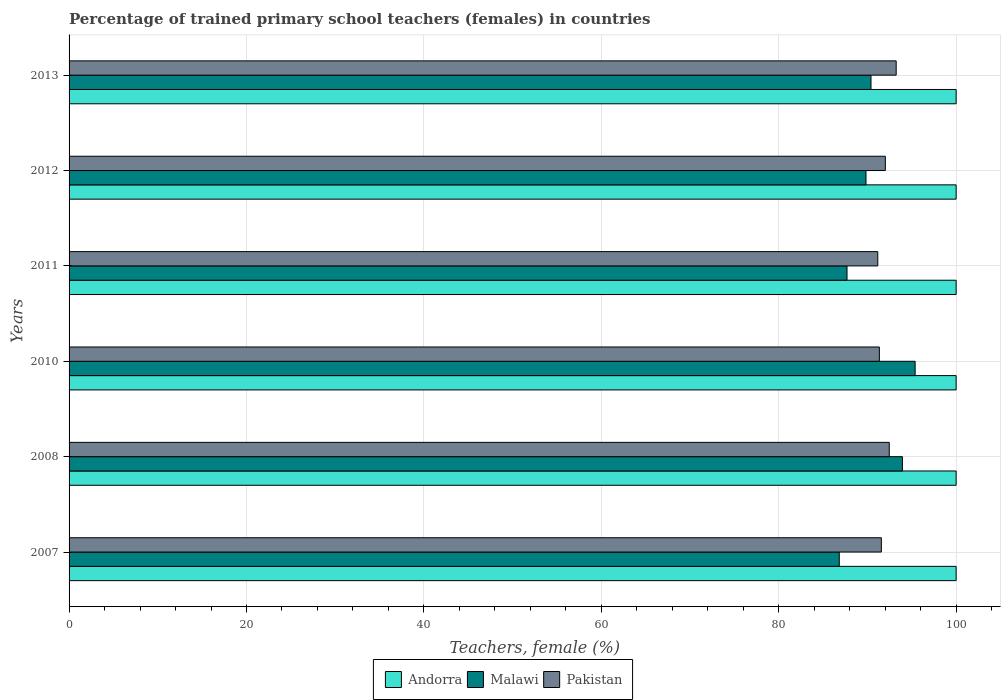How many different coloured bars are there?
Provide a succinct answer. 3. How many bars are there on the 3rd tick from the bottom?
Ensure brevity in your answer.  3. In how many cases, is the number of bars for a given year not equal to the number of legend labels?
Your response must be concise. 0. What is the percentage of trained primary school teachers (females) in Pakistan in 2013?
Ensure brevity in your answer.  93.24. Across all years, what is the maximum percentage of trained primary school teachers (females) in Malawi?
Make the answer very short. 95.38. Across all years, what is the minimum percentage of trained primary school teachers (females) in Pakistan?
Your response must be concise. 91.17. In which year was the percentage of trained primary school teachers (females) in Andorra minimum?
Your response must be concise. 2007. What is the total percentage of trained primary school teachers (females) in Malawi in the graph?
Offer a terse response. 544.08. What is the difference between the percentage of trained primary school teachers (females) in Pakistan in 2007 and that in 2010?
Provide a short and direct response. 0.23. What is the difference between the percentage of trained primary school teachers (females) in Malawi in 2008 and the percentage of trained primary school teachers (females) in Andorra in 2007?
Keep it short and to the point. -6.06. What is the average percentage of trained primary school teachers (females) in Malawi per year?
Offer a terse response. 90.68. In the year 2013, what is the difference between the percentage of trained primary school teachers (females) in Malawi and percentage of trained primary school teachers (females) in Andorra?
Provide a succinct answer. -9.6. Is the percentage of trained primary school teachers (females) in Malawi in 2007 less than that in 2012?
Offer a terse response. Yes. What is the difference between the highest and the second highest percentage of trained primary school teachers (females) in Pakistan?
Ensure brevity in your answer.  0.78. What is the difference between the highest and the lowest percentage of trained primary school teachers (females) in Malawi?
Offer a very short reply. 8.55. Is the sum of the percentage of trained primary school teachers (females) in Malawi in 2011 and 2012 greater than the maximum percentage of trained primary school teachers (females) in Andorra across all years?
Your answer should be compact. Yes. What does the 1st bar from the bottom in 2007 represents?
Your answer should be compact. Andorra. Is it the case that in every year, the sum of the percentage of trained primary school teachers (females) in Pakistan and percentage of trained primary school teachers (females) in Malawi is greater than the percentage of trained primary school teachers (females) in Andorra?
Give a very brief answer. Yes. What is the difference between two consecutive major ticks on the X-axis?
Keep it short and to the point. 20. Does the graph contain any zero values?
Your response must be concise. No. How are the legend labels stacked?
Your answer should be compact. Horizontal. What is the title of the graph?
Give a very brief answer. Percentage of trained primary school teachers (females) in countries. What is the label or title of the X-axis?
Keep it short and to the point. Teachers, female (%). What is the Teachers, female (%) of Malawi in 2007?
Offer a very short reply. 86.82. What is the Teachers, female (%) of Pakistan in 2007?
Make the answer very short. 91.57. What is the Teachers, female (%) of Andorra in 2008?
Provide a succinct answer. 100. What is the Teachers, female (%) of Malawi in 2008?
Provide a succinct answer. 93.94. What is the Teachers, female (%) of Pakistan in 2008?
Ensure brevity in your answer.  92.46. What is the Teachers, female (%) of Malawi in 2010?
Provide a short and direct response. 95.38. What is the Teachers, female (%) of Pakistan in 2010?
Your response must be concise. 91.34. What is the Teachers, female (%) of Andorra in 2011?
Give a very brief answer. 100. What is the Teachers, female (%) in Malawi in 2011?
Make the answer very short. 87.7. What is the Teachers, female (%) in Pakistan in 2011?
Provide a succinct answer. 91.17. What is the Teachers, female (%) in Andorra in 2012?
Offer a very short reply. 100. What is the Teachers, female (%) in Malawi in 2012?
Provide a succinct answer. 89.84. What is the Teachers, female (%) in Pakistan in 2012?
Provide a short and direct response. 92.02. What is the Teachers, female (%) in Andorra in 2013?
Give a very brief answer. 100. What is the Teachers, female (%) in Malawi in 2013?
Provide a short and direct response. 90.4. What is the Teachers, female (%) of Pakistan in 2013?
Your response must be concise. 93.24. Across all years, what is the maximum Teachers, female (%) of Andorra?
Your answer should be very brief. 100. Across all years, what is the maximum Teachers, female (%) in Malawi?
Provide a short and direct response. 95.38. Across all years, what is the maximum Teachers, female (%) of Pakistan?
Offer a terse response. 93.24. Across all years, what is the minimum Teachers, female (%) in Malawi?
Your answer should be compact. 86.82. Across all years, what is the minimum Teachers, female (%) of Pakistan?
Your response must be concise. 91.17. What is the total Teachers, female (%) of Andorra in the graph?
Provide a short and direct response. 600. What is the total Teachers, female (%) of Malawi in the graph?
Offer a very short reply. 544.08. What is the total Teachers, female (%) in Pakistan in the graph?
Give a very brief answer. 551.8. What is the difference between the Teachers, female (%) in Malawi in 2007 and that in 2008?
Give a very brief answer. -7.12. What is the difference between the Teachers, female (%) of Pakistan in 2007 and that in 2008?
Keep it short and to the point. -0.89. What is the difference between the Teachers, female (%) in Andorra in 2007 and that in 2010?
Offer a very short reply. 0. What is the difference between the Teachers, female (%) in Malawi in 2007 and that in 2010?
Keep it short and to the point. -8.55. What is the difference between the Teachers, female (%) of Pakistan in 2007 and that in 2010?
Your answer should be very brief. 0.23. What is the difference between the Teachers, female (%) of Andorra in 2007 and that in 2011?
Your answer should be compact. 0. What is the difference between the Teachers, female (%) in Malawi in 2007 and that in 2011?
Provide a succinct answer. -0.87. What is the difference between the Teachers, female (%) in Pakistan in 2007 and that in 2011?
Offer a terse response. 0.4. What is the difference between the Teachers, female (%) of Andorra in 2007 and that in 2012?
Make the answer very short. 0. What is the difference between the Teachers, female (%) in Malawi in 2007 and that in 2012?
Offer a very short reply. -3.01. What is the difference between the Teachers, female (%) in Pakistan in 2007 and that in 2012?
Offer a very short reply. -0.45. What is the difference between the Teachers, female (%) of Andorra in 2007 and that in 2013?
Provide a short and direct response. 0. What is the difference between the Teachers, female (%) in Malawi in 2007 and that in 2013?
Offer a terse response. -3.58. What is the difference between the Teachers, female (%) in Pakistan in 2007 and that in 2013?
Your answer should be very brief. -1.67. What is the difference between the Teachers, female (%) of Malawi in 2008 and that in 2010?
Make the answer very short. -1.43. What is the difference between the Teachers, female (%) of Pakistan in 2008 and that in 2010?
Keep it short and to the point. 1.12. What is the difference between the Teachers, female (%) in Malawi in 2008 and that in 2011?
Ensure brevity in your answer.  6.24. What is the difference between the Teachers, female (%) of Pakistan in 2008 and that in 2011?
Your answer should be compact. 1.29. What is the difference between the Teachers, female (%) in Andorra in 2008 and that in 2012?
Keep it short and to the point. 0. What is the difference between the Teachers, female (%) in Malawi in 2008 and that in 2012?
Provide a succinct answer. 4.1. What is the difference between the Teachers, female (%) of Pakistan in 2008 and that in 2012?
Your answer should be compact. 0.44. What is the difference between the Teachers, female (%) in Malawi in 2008 and that in 2013?
Your answer should be very brief. 3.54. What is the difference between the Teachers, female (%) in Pakistan in 2008 and that in 2013?
Make the answer very short. -0.78. What is the difference between the Teachers, female (%) in Andorra in 2010 and that in 2011?
Ensure brevity in your answer.  0. What is the difference between the Teachers, female (%) in Malawi in 2010 and that in 2011?
Offer a very short reply. 7.68. What is the difference between the Teachers, female (%) of Pakistan in 2010 and that in 2011?
Your answer should be compact. 0.18. What is the difference between the Teachers, female (%) in Andorra in 2010 and that in 2012?
Your answer should be very brief. 0. What is the difference between the Teachers, female (%) in Malawi in 2010 and that in 2012?
Keep it short and to the point. 5.54. What is the difference between the Teachers, female (%) of Pakistan in 2010 and that in 2012?
Your response must be concise. -0.68. What is the difference between the Teachers, female (%) in Malawi in 2010 and that in 2013?
Provide a short and direct response. 4.97. What is the difference between the Teachers, female (%) in Pakistan in 2010 and that in 2013?
Make the answer very short. -1.9. What is the difference between the Teachers, female (%) of Malawi in 2011 and that in 2012?
Your answer should be compact. -2.14. What is the difference between the Teachers, female (%) of Pakistan in 2011 and that in 2012?
Make the answer very short. -0.85. What is the difference between the Teachers, female (%) of Andorra in 2011 and that in 2013?
Your answer should be very brief. 0. What is the difference between the Teachers, female (%) of Malawi in 2011 and that in 2013?
Give a very brief answer. -2.7. What is the difference between the Teachers, female (%) in Pakistan in 2011 and that in 2013?
Provide a short and direct response. -2.07. What is the difference between the Teachers, female (%) of Malawi in 2012 and that in 2013?
Give a very brief answer. -0.56. What is the difference between the Teachers, female (%) of Pakistan in 2012 and that in 2013?
Your answer should be very brief. -1.22. What is the difference between the Teachers, female (%) in Andorra in 2007 and the Teachers, female (%) in Malawi in 2008?
Ensure brevity in your answer.  6.06. What is the difference between the Teachers, female (%) of Andorra in 2007 and the Teachers, female (%) of Pakistan in 2008?
Ensure brevity in your answer.  7.54. What is the difference between the Teachers, female (%) in Malawi in 2007 and the Teachers, female (%) in Pakistan in 2008?
Offer a very short reply. -5.64. What is the difference between the Teachers, female (%) of Andorra in 2007 and the Teachers, female (%) of Malawi in 2010?
Give a very brief answer. 4.62. What is the difference between the Teachers, female (%) of Andorra in 2007 and the Teachers, female (%) of Pakistan in 2010?
Ensure brevity in your answer.  8.66. What is the difference between the Teachers, female (%) of Malawi in 2007 and the Teachers, female (%) of Pakistan in 2010?
Make the answer very short. -4.52. What is the difference between the Teachers, female (%) in Andorra in 2007 and the Teachers, female (%) in Malawi in 2011?
Give a very brief answer. 12.3. What is the difference between the Teachers, female (%) of Andorra in 2007 and the Teachers, female (%) of Pakistan in 2011?
Keep it short and to the point. 8.83. What is the difference between the Teachers, female (%) of Malawi in 2007 and the Teachers, female (%) of Pakistan in 2011?
Give a very brief answer. -4.34. What is the difference between the Teachers, female (%) of Andorra in 2007 and the Teachers, female (%) of Malawi in 2012?
Offer a very short reply. 10.16. What is the difference between the Teachers, female (%) in Andorra in 2007 and the Teachers, female (%) in Pakistan in 2012?
Give a very brief answer. 7.98. What is the difference between the Teachers, female (%) in Malawi in 2007 and the Teachers, female (%) in Pakistan in 2012?
Provide a short and direct response. -5.2. What is the difference between the Teachers, female (%) of Andorra in 2007 and the Teachers, female (%) of Malawi in 2013?
Your answer should be compact. 9.6. What is the difference between the Teachers, female (%) in Andorra in 2007 and the Teachers, female (%) in Pakistan in 2013?
Give a very brief answer. 6.76. What is the difference between the Teachers, female (%) of Malawi in 2007 and the Teachers, female (%) of Pakistan in 2013?
Provide a succinct answer. -6.42. What is the difference between the Teachers, female (%) of Andorra in 2008 and the Teachers, female (%) of Malawi in 2010?
Offer a terse response. 4.62. What is the difference between the Teachers, female (%) in Andorra in 2008 and the Teachers, female (%) in Pakistan in 2010?
Your answer should be compact. 8.66. What is the difference between the Teachers, female (%) in Malawi in 2008 and the Teachers, female (%) in Pakistan in 2010?
Provide a short and direct response. 2.6. What is the difference between the Teachers, female (%) in Andorra in 2008 and the Teachers, female (%) in Malawi in 2011?
Give a very brief answer. 12.3. What is the difference between the Teachers, female (%) in Andorra in 2008 and the Teachers, female (%) in Pakistan in 2011?
Offer a terse response. 8.83. What is the difference between the Teachers, female (%) of Malawi in 2008 and the Teachers, female (%) of Pakistan in 2011?
Make the answer very short. 2.77. What is the difference between the Teachers, female (%) in Andorra in 2008 and the Teachers, female (%) in Malawi in 2012?
Your answer should be compact. 10.16. What is the difference between the Teachers, female (%) in Andorra in 2008 and the Teachers, female (%) in Pakistan in 2012?
Your answer should be very brief. 7.98. What is the difference between the Teachers, female (%) in Malawi in 2008 and the Teachers, female (%) in Pakistan in 2012?
Provide a short and direct response. 1.92. What is the difference between the Teachers, female (%) in Andorra in 2008 and the Teachers, female (%) in Malawi in 2013?
Offer a terse response. 9.6. What is the difference between the Teachers, female (%) of Andorra in 2008 and the Teachers, female (%) of Pakistan in 2013?
Give a very brief answer. 6.76. What is the difference between the Teachers, female (%) in Malawi in 2008 and the Teachers, female (%) in Pakistan in 2013?
Keep it short and to the point. 0.7. What is the difference between the Teachers, female (%) of Andorra in 2010 and the Teachers, female (%) of Malawi in 2011?
Ensure brevity in your answer.  12.3. What is the difference between the Teachers, female (%) of Andorra in 2010 and the Teachers, female (%) of Pakistan in 2011?
Ensure brevity in your answer.  8.83. What is the difference between the Teachers, female (%) in Malawi in 2010 and the Teachers, female (%) in Pakistan in 2011?
Give a very brief answer. 4.21. What is the difference between the Teachers, female (%) of Andorra in 2010 and the Teachers, female (%) of Malawi in 2012?
Keep it short and to the point. 10.16. What is the difference between the Teachers, female (%) of Andorra in 2010 and the Teachers, female (%) of Pakistan in 2012?
Provide a short and direct response. 7.98. What is the difference between the Teachers, female (%) of Malawi in 2010 and the Teachers, female (%) of Pakistan in 2012?
Your answer should be very brief. 3.36. What is the difference between the Teachers, female (%) in Andorra in 2010 and the Teachers, female (%) in Malawi in 2013?
Give a very brief answer. 9.6. What is the difference between the Teachers, female (%) in Andorra in 2010 and the Teachers, female (%) in Pakistan in 2013?
Your answer should be very brief. 6.76. What is the difference between the Teachers, female (%) in Malawi in 2010 and the Teachers, female (%) in Pakistan in 2013?
Give a very brief answer. 2.14. What is the difference between the Teachers, female (%) of Andorra in 2011 and the Teachers, female (%) of Malawi in 2012?
Give a very brief answer. 10.16. What is the difference between the Teachers, female (%) of Andorra in 2011 and the Teachers, female (%) of Pakistan in 2012?
Provide a short and direct response. 7.98. What is the difference between the Teachers, female (%) of Malawi in 2011 and the Teachers, female (%) of Pakistan in 2012?
Your answer should be compact. -4.32. What is the difference between the Teachers, female (%) in Andorra in 2011 and the Teachers, female (%) in Malawi in 2013?
Your answer should be compact. 9.6. What is the difference between the Teachers, female (%) in Andorra in 2011 and the Teachers, female (%) in Pakistan in 2013?
Your answer should be very brief. 6.76. What is the difference between the Teachers, female (%) of Malawi in 2011 and the Teachers, female (%) of Pakistan in 2013?
Offer a very short reply. -5.54. What is the difference between the Teachers, female (%) in Andorra in 2012 and the Teachers, female (%) in Malawi in 2013?
Make the answer very short. 9.6. What is the difference between the Teachers, female (%) of Andorra in 2012 and the Teachers, female (%) of Pakistan in 2013?
Keep it short and to the point. 6.76. What is the difference between the Teachers, female (%) of Malawi in 2012 and the Teachers, female (%) of Pakistan in 2013?
Provide a short and direct response. -3.4. What is the average Teachers, female (%) in Andorra per year?
Offer a terse response. 100. What is the average Teachers, female (%) of Malawi per year?
Make the answer very short. 90.68. What is the average Teachers, female (%) of Pakistan per year?
Provide a short and direct response. 91.97. In the year 2007, what is the difference between the Teachers, female (%) in Andorra and Teachers, female (%) in Malawi?
Your answer should be very brief. 13.18. In the year 2007, what is the difference between the Teachers, female (%) in Andorra and Teachers, female (%) in Pakistan?
Offer a very short reply. 8.43. In the year 2007, what is the difference between the Teachers, female (%) of Malawi and Teachers, female (%) of Pakistan?
Keep it short and to the point. -4.75. In the year 2008, what is the difference between the Teachers, female (%) of Andorra and Teachers, female (%) of Malawi?
Make the answer very short. 6.06. In the year 2008, what is the difference between the Teachers, female (%) of Andorra and Teachers, female (%) of Pakistan?
Offer a terse response. 7.54. In the year 2008, what is the difference between the Teachers, female (%) of Malawi and Teachers, female (%) of Pakistan?
Offer a very short reply. 1.48. In the year 2010, what is the difference between the Teachers, female (%) in Andorra and Teachers, female (%) in Malawi?
Ensure brevity in your answer.  4.62. In the year 2010, what is the difference between the Teachers, female (%) of Andorra and Teachers, female (%) of Pakistan?
Your answer should be very brief. 8.66. In the year 2010, what is the difference between the Teachers, female (%) in Malawi and Teachers, female (%) in Pakistan?
Your response must be concise. 4.03. In the year 2011, what is the difference between the Teachers, female (%) of Andorra and Teachers, female (%) of Malawi?
Keep it short and to the point. 12.3. In the year 2011, what is the difference between the Teachers, female (%) in Andorra and Teachers, female (%) in Pakistan?
Give a very brief answer. 8.83. In the year 2011, what is the difference between the Teachers, female (%) of Malawi and Teachers, female (%) of Pakistan?
Give a very brief answer. -3.47. In the year 2012, what is the difference between the Teachers, female (%) in Andorra and Teachers, female (%) in Malawi?
Keep it short and to the point. 10.16. In the year 2012, what is the difference between the Teachers, female (%) in Andorra and Teachers, female (%) in Pakistan?
Your response must be concise. 7.98. In the year 2012, what is the difference between the Teachers, female (%) in Malawi and Teachers, female (%) in Pakistan?
Ensure brevity in your answer.  -2.18. In the year 2013, what is the difference between the Teachers, female (%) in Andorra and Teachers, female (%) in Malawi?
Keep it short and to the point. 9.6. In the year 2013, what is the difference between the Teachers, female (%) in Andorra and Teachers, female (%) in Pakistan?
Offer a very short reply. 6.76. In the year 2013, what is the difference between the Teachers, female (%) of Malawi and Teachers, female (%) of Pakistan?
Provide a short and direct response. -2.84. What is the ratio of the Teachers, female (%) of Malawi in 2007 to that in 2008?
Make the answer very short. 0.92. What is the ratio of the Teachers, female (%) of Andorra in 2007 to that in 2010?
Offer a terse response. 1. What is the ratio of the Teachers, female (%) in Malawi in 2007 to that in 2010?
Ensure brevity in your answer.  0.91. What is the ratio of the Teachers, female (%) of Pakistan in 2007 to that in 2010?
Offer a terse response. 1. What is the ratio of the Teachers, female (%) of Malawi in 2007 to that in 2012?
Offer a very short reply. 0.97. What is the ratio of the Teachers, female (%) in Malawi in 2007 to that in 2013?
Offer a very short reply. 0.96. What is the ratio of the Teachers, female (%) in Pakistan in 2007 to that in 2013?
Give a very brief answer. 0.98. What is the ratio of the Teachers, female (%) of Malawi in 2008 to that in 2010?
Make the answer very short. 0.98. What is the ratio of the Teachers, female (%) of Pakistan in 2008 to that in 2010?
Give a very brief answer. 1.01. What is the ratio of the Teachers, female (%) of Malawi in 2008 to that in 2011?
Provide a succinct answer. 1.07. What is the ratio of the Teachers, female (%) of Pakistan in 2008 to that in 2011?
Keep it short and to the point. 1.01. What is the ratio of the Teachers, female (%) in Andorra in 2008 to that in 2012?
Offer a terse response. 1. What is the ratio of the Teachers, female (%) in Malawi in 2008 to that in 2012?
Offer a terse response. 1.05. What is the ratio of the Teachers, female (%) in Malawi in 2008 to that in 2013?
Make the answer very short. 1.04. What is the ratio of the Teachers, female (%) of Andorra in 2010 to that in 2011?
Keep it short and to the point. 1. What is the ratio of the Teachers, female (%) in Malawi in 2010 to that in 2011?
Ensure brevity in your answer.  1.09. What is the ratio of the Teachers, female (%) of Andorra in 2010 to that in 2012?
Keep it short and to the point. 1. What is the ratio of the Teachers, female (%) of Malawi in 2010 to that in 2012?
Offer a very short reply. 1.06. What is the ratio of the Teachers, female (%) in Andorra in 2010 to that in 2013?
Give a very brief answer. 1. What is the ratio of the Teachers, female (%) of Malawi in 2010 to that in 2013?
Provide a succinct answer. 1.05. What is the ratio of the Teachers, female (%) of Pakistan in 2010 to that in 2013?
Your answer should be very brief. 0.98. What is the ratio of the Teachers, female (%) of Malawi in 2011 to that in 2012?
Ensure brevity in your answer.  0.98. What is the ratio of the Teachers, female (%) in Pakistan in 2011 to that in 2012?
Your answer should be compact. 0.99. What is the ratio of the Teachers, female (%) of Andorra in 2011 to that in 2013?
Offer a very short reply. 1. What is the ratio of the Teachers, female (%) of Malawi in 2011 to that in 2013?
Provide a succinct answer. 0.97. What is the ratio of the Teachers, female (%) in Pakistan in 2011 to that in 2013?
Give a very brief answer. 0.98. What is the ratio of the Teachers, female (%) in Pakistan in 2012 to that in 2013?
Ensure brevity in your answer.  0.99. What is the difference between the highest and the second highest Teachers, female (%) of Andorra?
Make the answer very short. 0. What is the difference between the highest and the second highest Teachers, female (%) of Malawi?
Keep it short and to the point. 1.43. What is the difference between the highest and the second highest Teachers, female (%) of Pakistan?
Your answer should be compact. 0.78. What is the difference between the highest and the lowest Teachers, female (%) of Malawi?
Give a very brief answer. 8.55. What is the difference between the highest and the lowest Teachers, female (%) of Pakistan?
Make the answer very short. 2.07. 